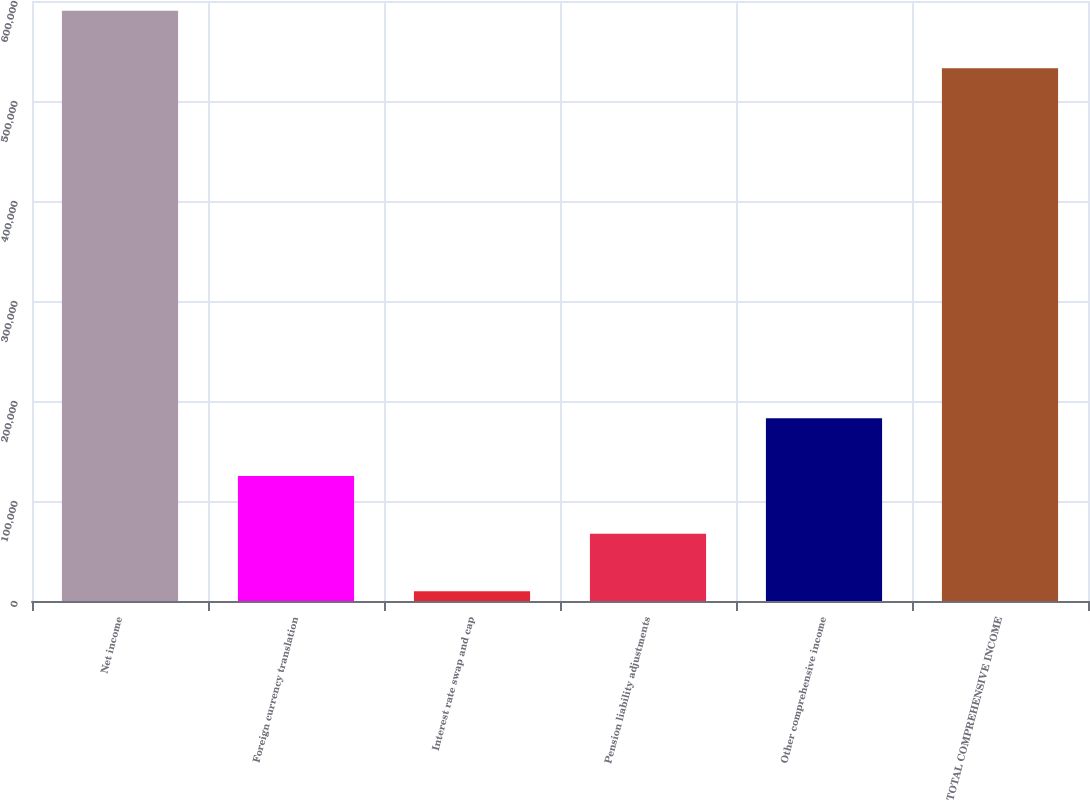<chart> <loc_0><loc_0><loc_500><loc_500><bar_chart><fcel>Net income<fcel>Foreign currency translation<fcel>Interest rate swap and cap<fcel>Pension liability adjustments<fcel>Other comprehensive income<fcel>TOTAL COMPREHENSIVE INCOME<nl><fcel>590313<fcel>125001<fcel>9648<fcel>67324.6<fcel>182678<fcel>532636<nl></chart> 